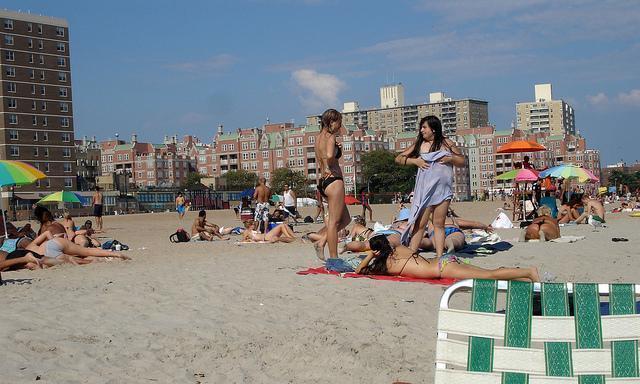The person under the orange umbrella is whom?
Select the accurate response from the four choices given to answer the question.
Options: Dog walker, police officer, queen, life guard. Life guard. 